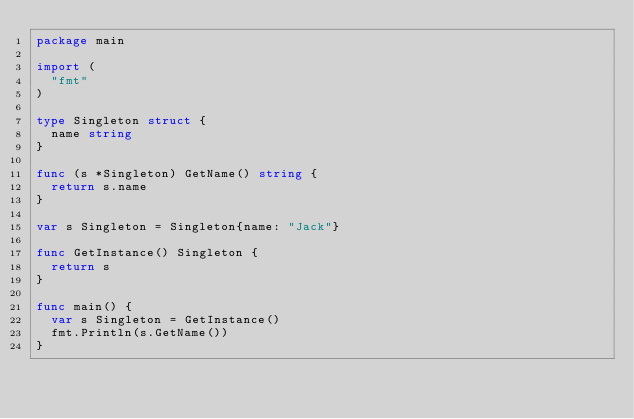Convert code to text. <code><loc_0><loc_0><loc_500><loc_500><_Go_>package main

import (
	"fmt"
)

type Singleton struct {
	name string
}

func (s *Singleton) GetName() string {
	return s.name
}

var s Singleton = Singleton{name: "Jack"}

func GetInstance() Singleton {
	return s
}

func main() {
	var s Singleton = GetInstance()
	fmt.Println(s.GetName())
}
</code> 